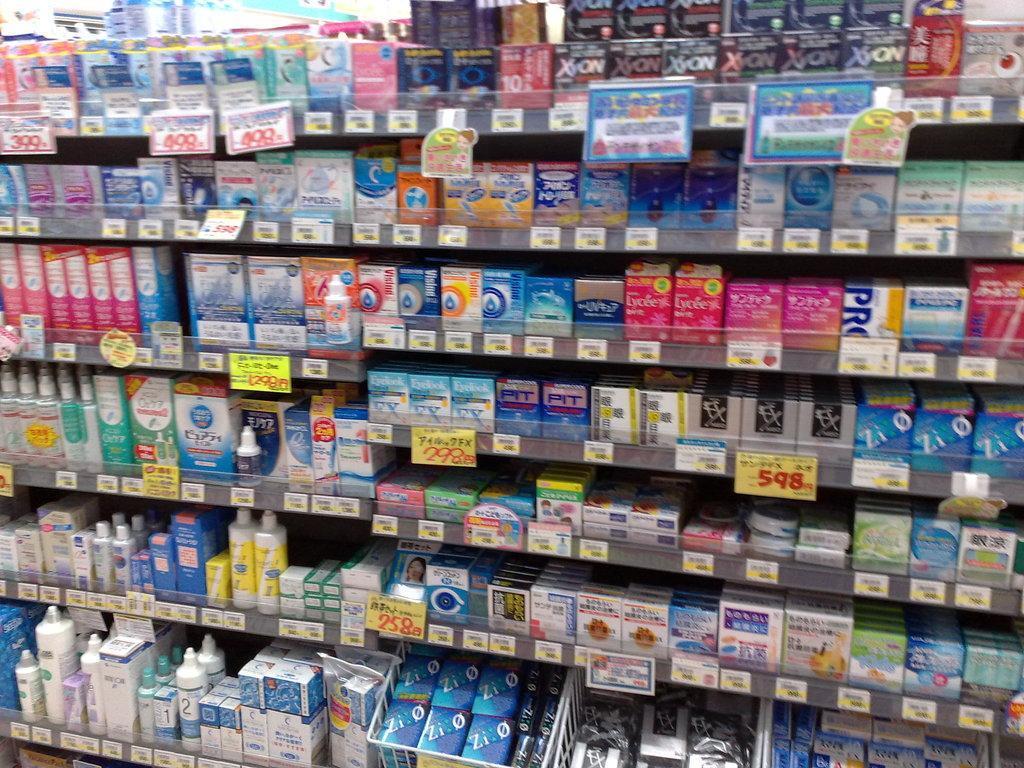In one or two sentences, can you explain what this image depicts? In this image we can see the different kinds of cartons and containers arranged in the shelves and information boards. 